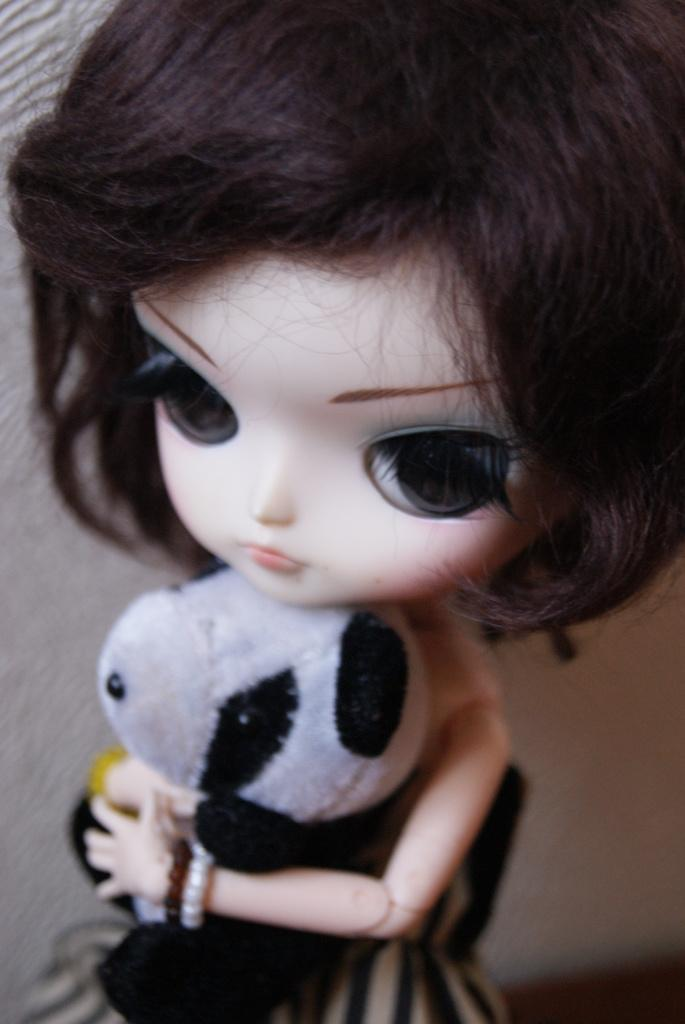How many toys are present in the image? There are two toys in the image. What type of fog can be seen surrounding the toys in the image? There is no fog present in the image; it only features two toys. What type of pickle is stored in the jar next to the toys in the image? There is no jar or pickle present in the image; it only features two toys. 